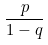Convert formula to latex. <formula><loc_0><loc_0><loc_500><loc_500>\frac { p } { 1 - q }</formula> 